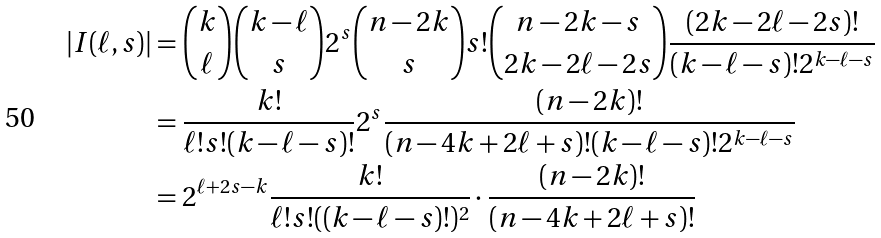Convert formula to latex. <formula><loc_0><loc_0><loc_500><loc_500>| I ( \ell , s ) | & = \binom { k } { \ell } \binom { k - \ell } { s } 2 ^ { s } \binom { n - 2 k } { s } s ! \binom { n - 2 k - s } { 2 k - 2 \ell - 2 s } \frac { ( 2 k - 2 \ell - 2 s ) ! } { ( k - \ell - s ) ! 2 ^ { k - \ell - s } } \\ & = \frac { k ! } { \ell ! s ! ( k - \ell - s ) ! } 2 ^ { s } \frac { ( n - 2 k ) ! } { ( n - 4 k + 2 \ell + s ) ! ( k - \ell - s ) ! 2 ^ { k - \ell - s } } \\ & = 2 ^ { \ell + 2 s - k } \frac { k ! } { \ell ! s ! ( ( k - \ell - s ) ! ) ^ { 2 } } \cdot \frac { ( n - 2 k ) ! } { ( n - 4 k + 2 \ell + s ) ! }</formula> 